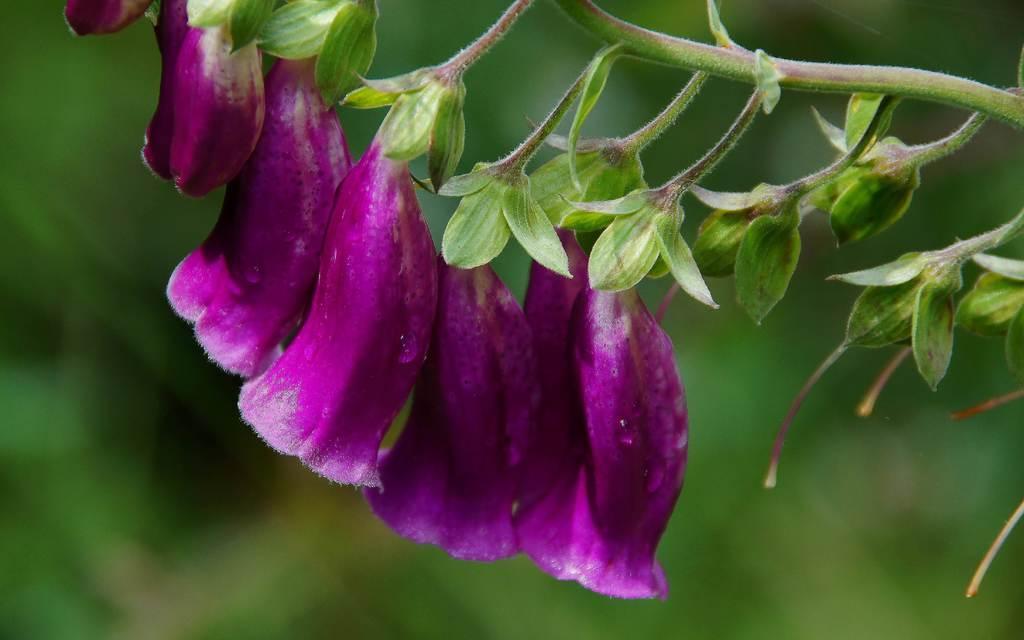Please provide a concise description of this image. In the image there are beautiful violet flowers to a plant and the background of the flowers is blur. 